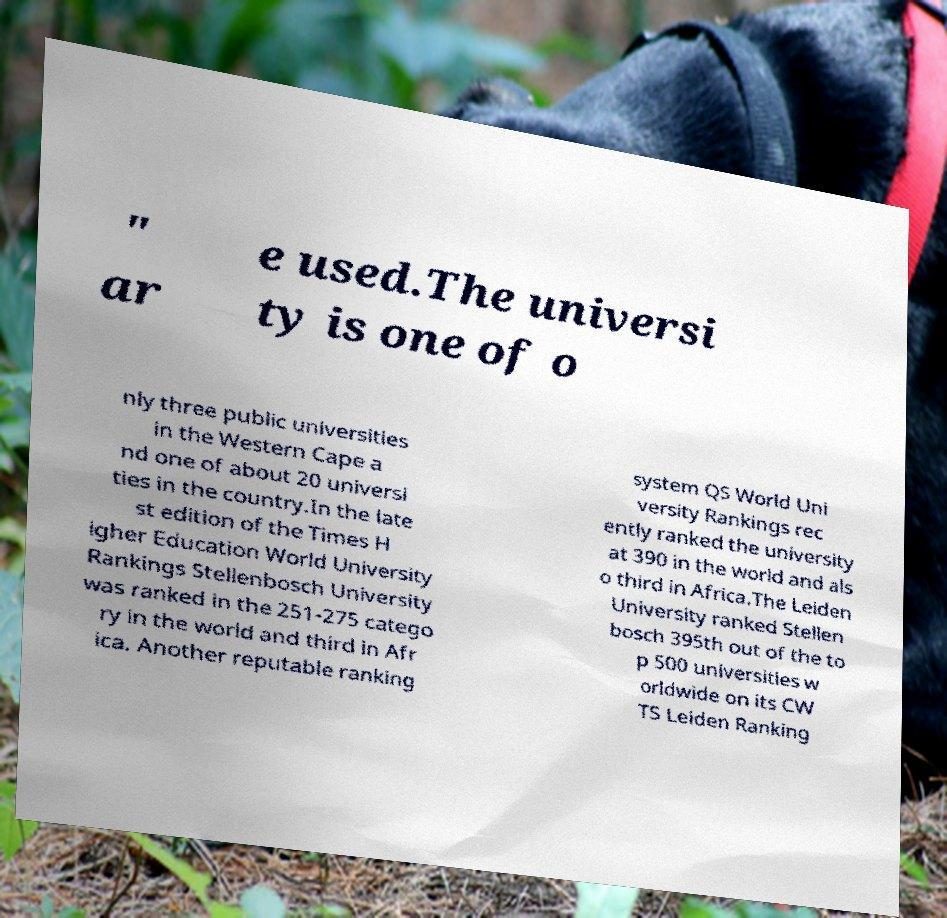Please identify and transcribe the text found in this image. " ar e used.The universi ty is one of o nly three public universities in the Western Cape a nd one of about 20 universi ties in the country.In the late st edition of the Times H igher Education World University Rankings Stellenbosch University was ranked in the 251-275 catego ry in the world and third in Afr ica. Another reputable ranking system QS World Uni versity Rankings rec ently ranked the university at 390 in the world and als o third in Africa.The Leiden University ranked Stellen bosch 395th out of the to p 500 universities w orldwide on its CW TS Leiden Ranking 